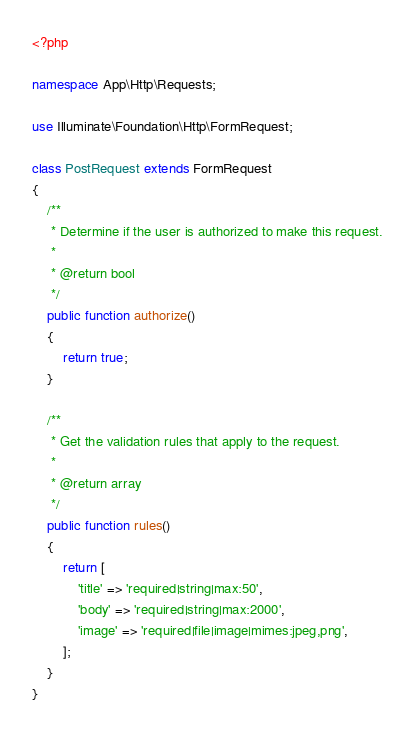<code> <loc_0><loc_0><loc_500><loc_500><_PHP_><?php

namespace App\Http\Requests;

use Illuminate\Foundation\Http\FormRequest;

class PostRequest extends FormRequest
{
    /**
     * Determine if the user is authorized to make this request.
     *
     * @return bool
     */
    public function authorize()
    {
        return true;
    }

    /**
     * Get the validation rules that apply to the request.
     *
     * @return array
     */
    public function rules()
    {
        return [
            'title' => 'required|string|max:50',
            'body' => 'required|string|max:2000',
            'image' => 'required|file|image|mimes:jpeg,png',
        ];
    }
}
</code> 